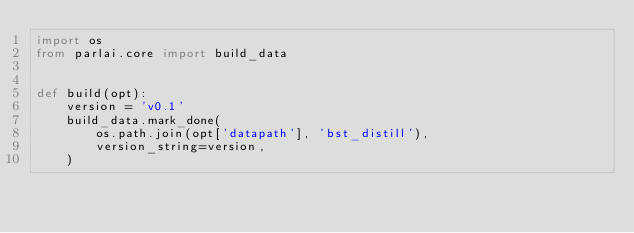<code> <loc_0><loc_0><loc_500><loc_500><_Python_>import os
from parlai.core import build_data


def build(opt):
    version = 'v0.1'
    build_data.mark_done(
        os.path.join(opt['datapath'], 'bst_distill'),
        version_string=version,
    )
</code> 